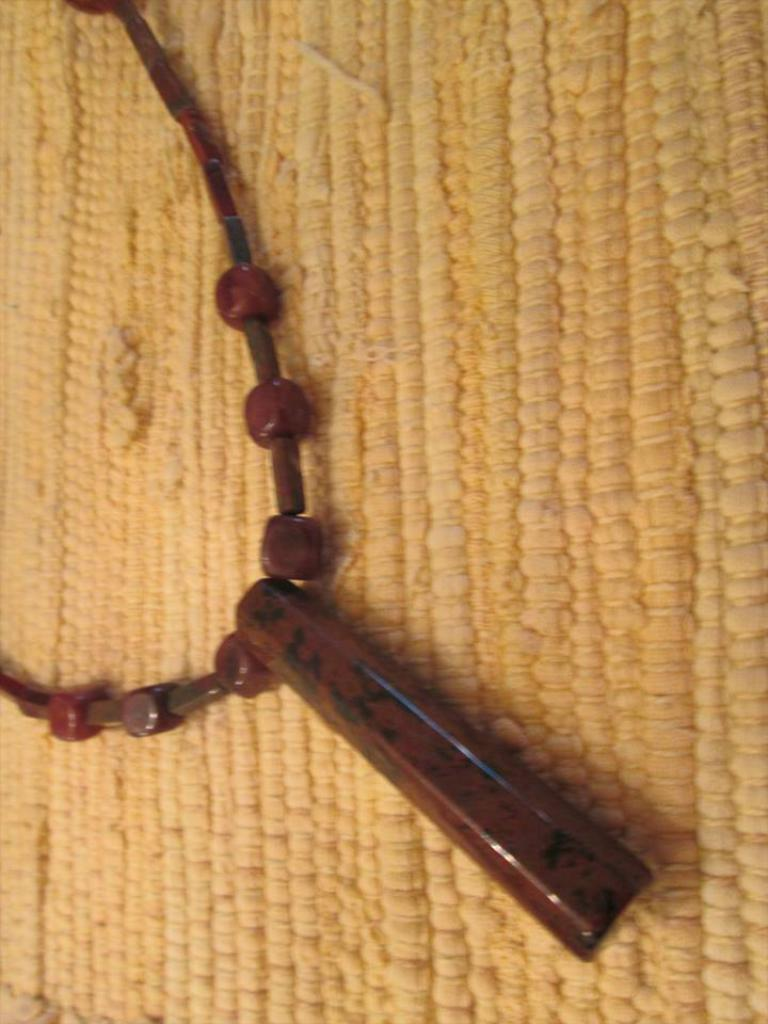What object can be seen in the image? There is an ornament in the image. Where is the ornament placed? The ornament is on a mat. Can you tell me how many times the ornament bounces on the tramp in the image? There is no tramp present in the image, so the ornament cannot bounce on it. 